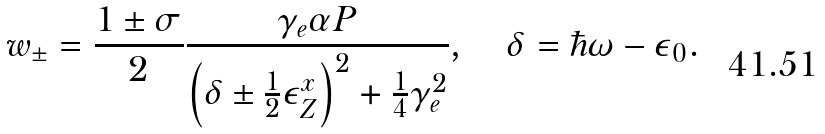<formula> <loc_0><loc_0><loc_500><loc_500>w _ { \pm } = \frac { 1 \pm \sigma } { 2 } \frac { \gamma _ { e } \alpha P } { \left ( \delta \pm \frac { 1 } { 2 } \epsilon _ { Z } ^ { x } \right ) ^ { 2 } + \frac { 1 } { 4 } \gamma _ { e } ^ { 2 } } , \quad \delta = \hbar { \omega } - \epsilon _ { 0 } .</formula> 